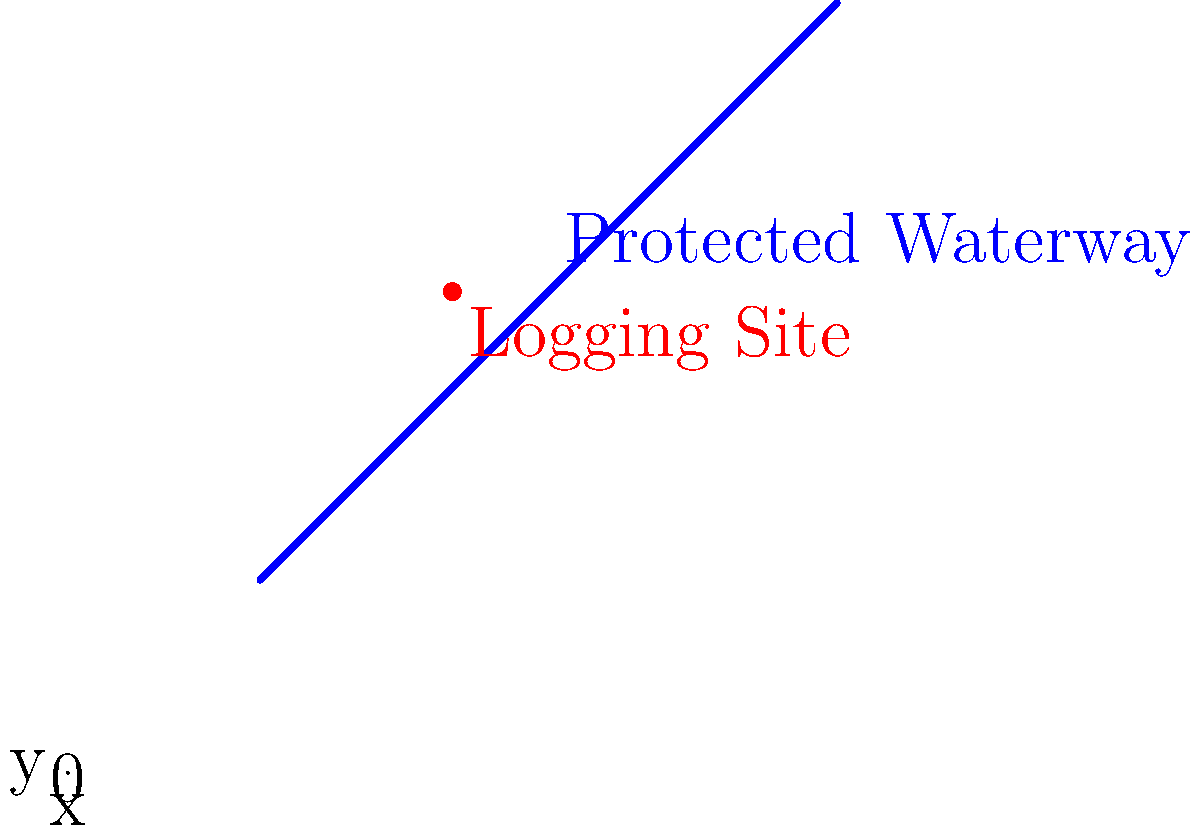A protected waterway runs diagonally across a forest area as shown in the coordinate grid above. Logging activities are not permitted within a 3-unit buffer zone on either side of the waterway. A potential logging site is located at coordinates (4, 5). Determine if this site is within the allowed logging area or if it falls within the protected buffer zone. To solve this problem, we need to follow these steps:

1) First, we need to find the equation of the line representing the waterway. From the graph, we can see it passes through (2,2) and (8,8). Using the point-slope form:

   $y - y_1 = m(x - x_1)$
   
   where $m = \frac{y_2 - y_1}{x_2 - x_1} = \frac{8-2}{8-2} = 1$

   So, the equation is $y - 2 = 1(x - 2)$ or $y = x$

2) Now, we need to calculate the perpendicular distance from the point (4,5) to this line.
   The formula for the distance $d$ from a point $(x_0, y_0)$ to a line $Ax + By + C = 0$ is:
   
   $d = \frac{|Ax_0 + By_0 + C|}{\sqrt{A^2 + B^2}}$

3) Our line $y = x$ can be rewritten as $x - y = 0$, so $A=1$, $B=-1$, and $C=0$

4) Plugging in our values:

   $d = \frac{|1(4) + (-1)(5) + 0|}{\sqrt{1^2 + (-1)^2}} = \frac{|-1|}{\sqrt{2}} = \frac{1}{\sqrt{2}} \approx 0.707$

5) Convert this to units on our grid:
   $0.707 * \sqrt{2} = 1$ unit

6) Since the distance is 1 unit and the buffer zone is 3 units, the logging site is within the allowed area.
Answer: The site is within the allowed logging area. 